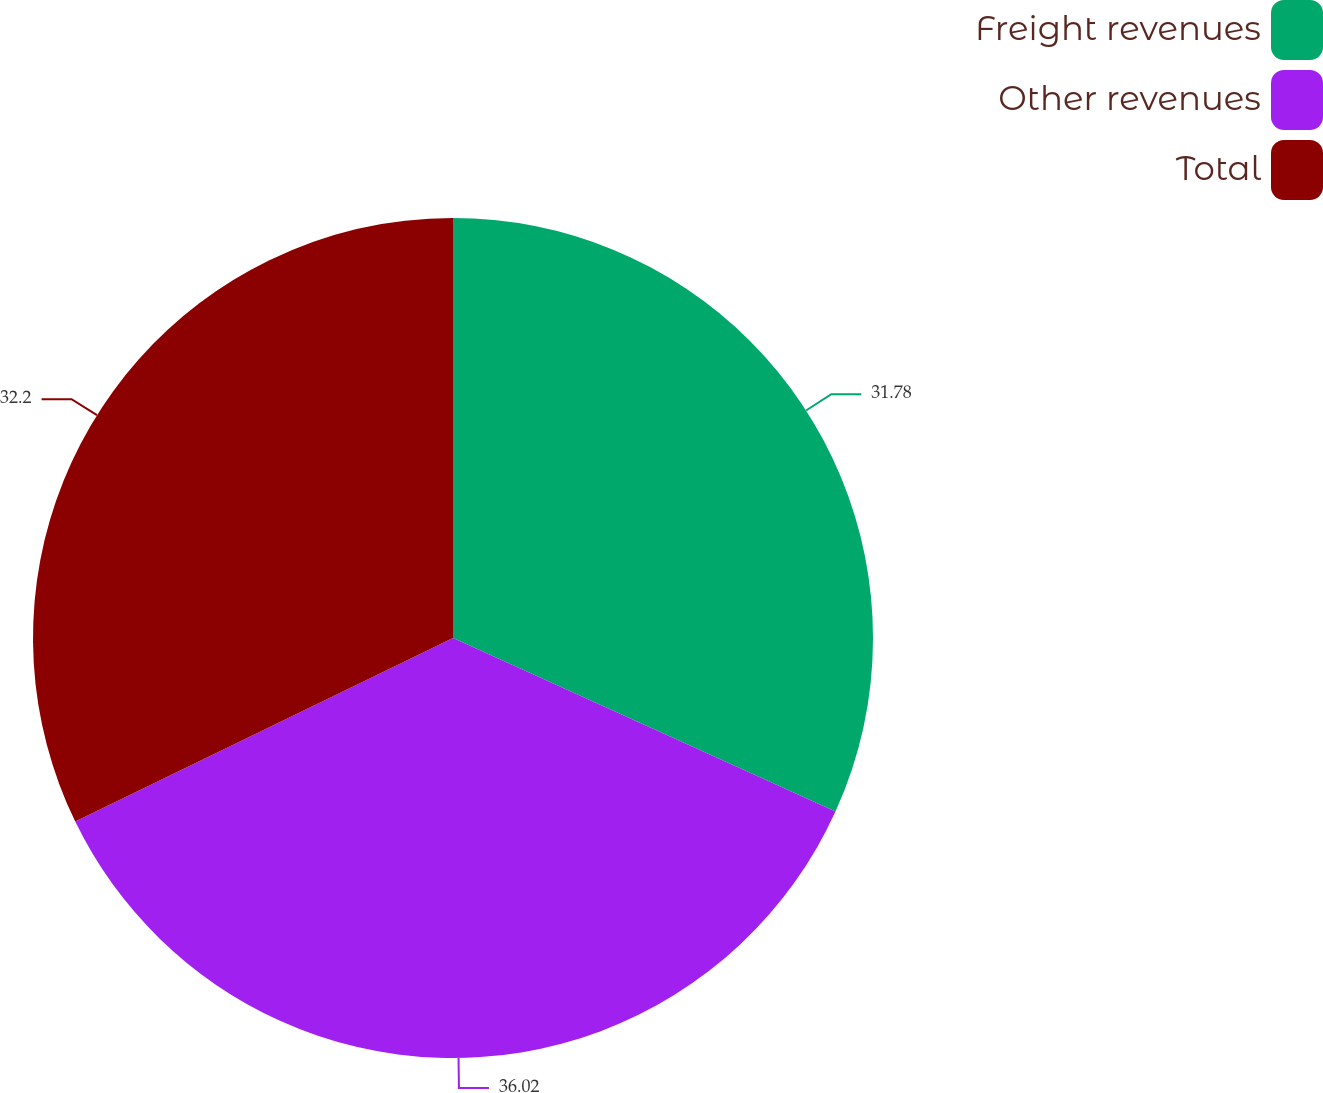Convert chart. <chart><loc_0><loc_0><loc_500><loc_500><pie_chart><fcel>Freight revenues<fcel>Other revenues<fcel>Total<nl><fcel>31.78%<fcel>36.02%<fcel>32.2%<nl></chart> 